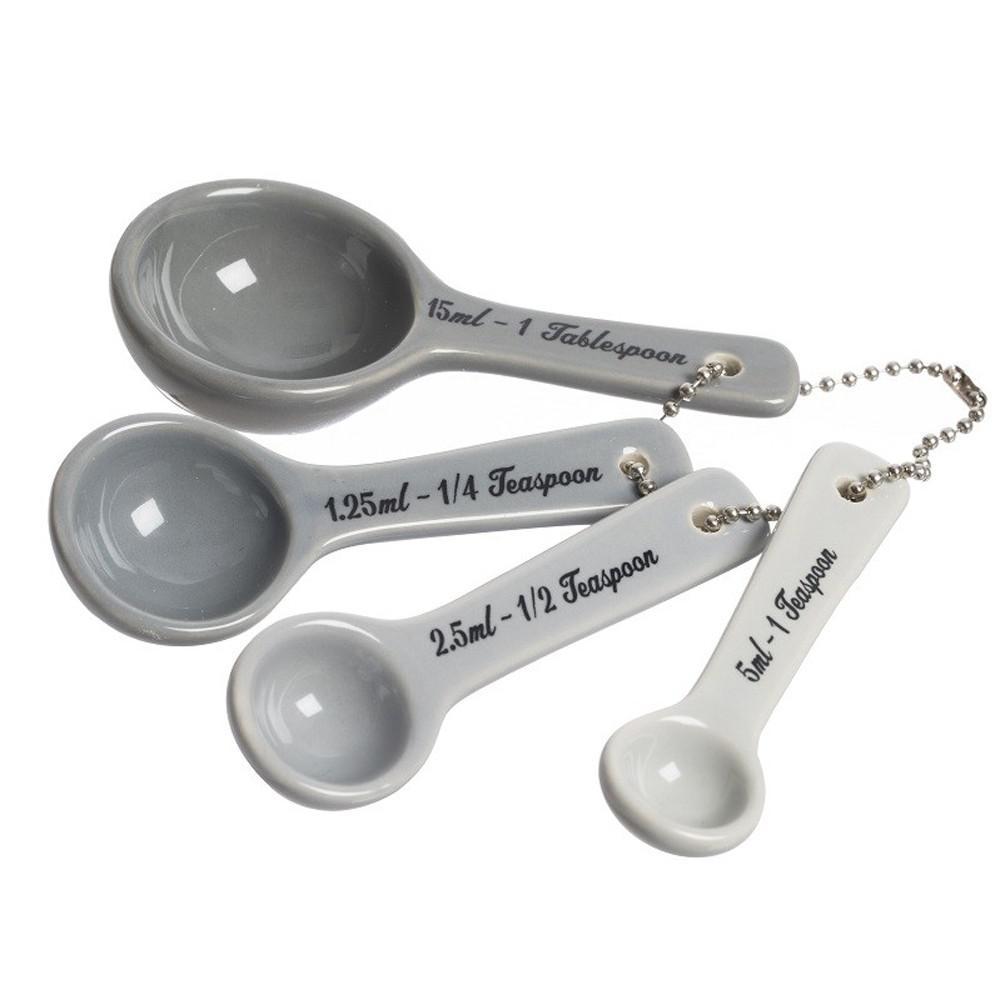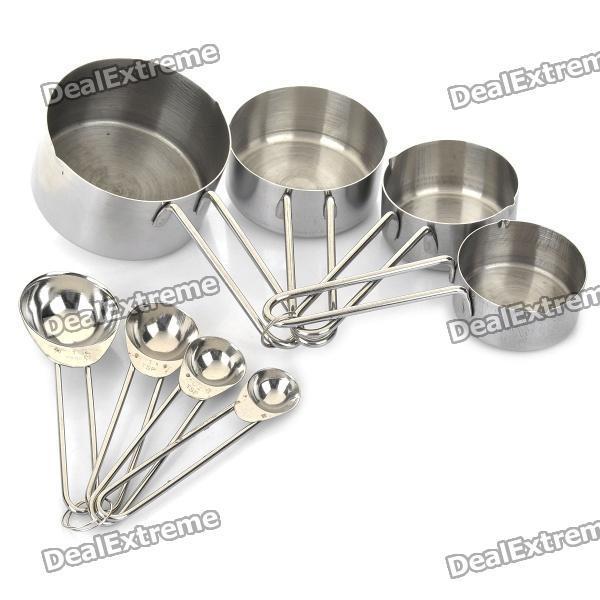The first image is the image on the left, the second image is the image on the right. Assess this claim about the two images: "One the set of measuring spoons is white with black handles.". Correct or not? Answer yes or no. No. 